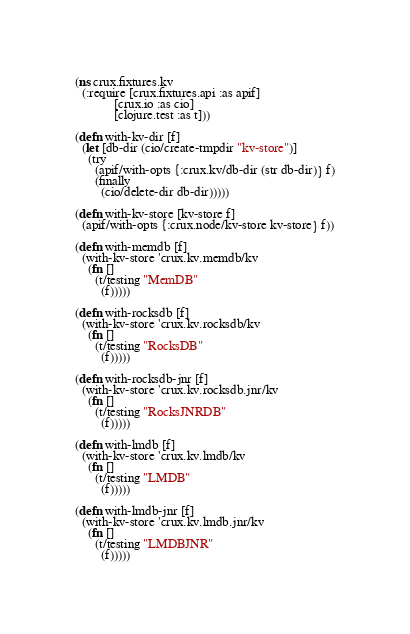Convert code to text. <code><loc_0><loc_0><loc_500><loc_500><_Clojure_>(ns crux.fixtures.kv
  (:require [crux.fixtures.api :as apif]
            [crux.io :as cio]
            [clojure.test :as t]))

(defn with-kv-dir [f]
  (let [db-dir (cio/create-tmpdir "kv-store")]
    (try
      (apif/with-opts {:crux.kv/db-dir (str db-dir)} f)
      (finally
        (cio/delete-dir db-dir)))))

(defn with-kv-store [kv-store f]
  (apif/with-opts {:crux.node/kv-store kv-store} f))

(defn with-memdb [f]
  (with-kv-store 'crux.kv.memdb/kv
    (fn []
      (t/testing "MemDB"
        (f)))))

(defn with-rocksdb [f]
  (with-kv-store 'crux.kv.rocksdb/kv
    (fn []
      (t/testing "RocksDB"
        (f)))))

(defn with-rocksdb-jnr [f]
  (with-kv-store 'crux.kv.rocksdb.jnr/kv
    (fn []
      (t/testing "RocksJNRDB"
        (f)))))

(defn with-lmdb [f]
  (with-kv-store 'crux.kv.lmdb/kv
    (fn []
      (t/testing "LMDB"
        (f)))))

(defn with-lmdb-jnr [f]
  (with-kv-store 'crux.kv.lmdb.jnr/kv
    (fn []
      (t/testing "LMDBJNR"
        (f)))))
</code> 